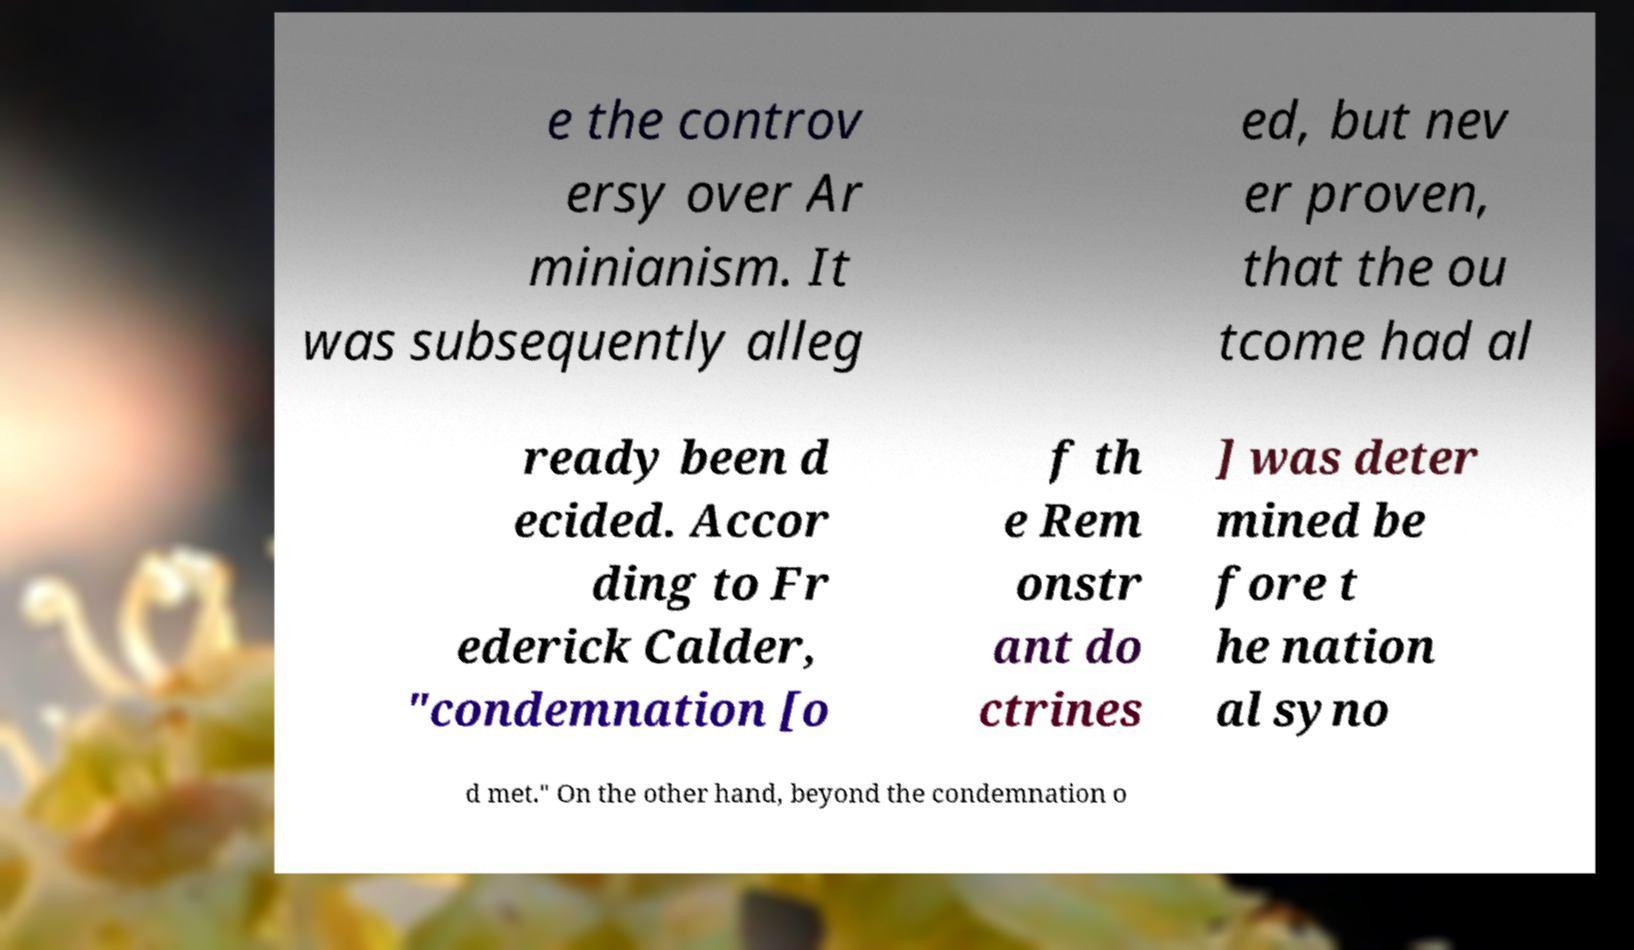Please read and relay the text visible in this image. What does it say? e the controv ersy over Ar minianism. It was subsequently alleg ed, but nev er proven, that the ou tcome had al ready been d ecided. Accor ding to Fr ederick Calder, "condemnation [o f th e Rem onstr ant do ctrines ] was deter mined be fore t he nation al syno d met." On the other hand, beyond the condemnation o 